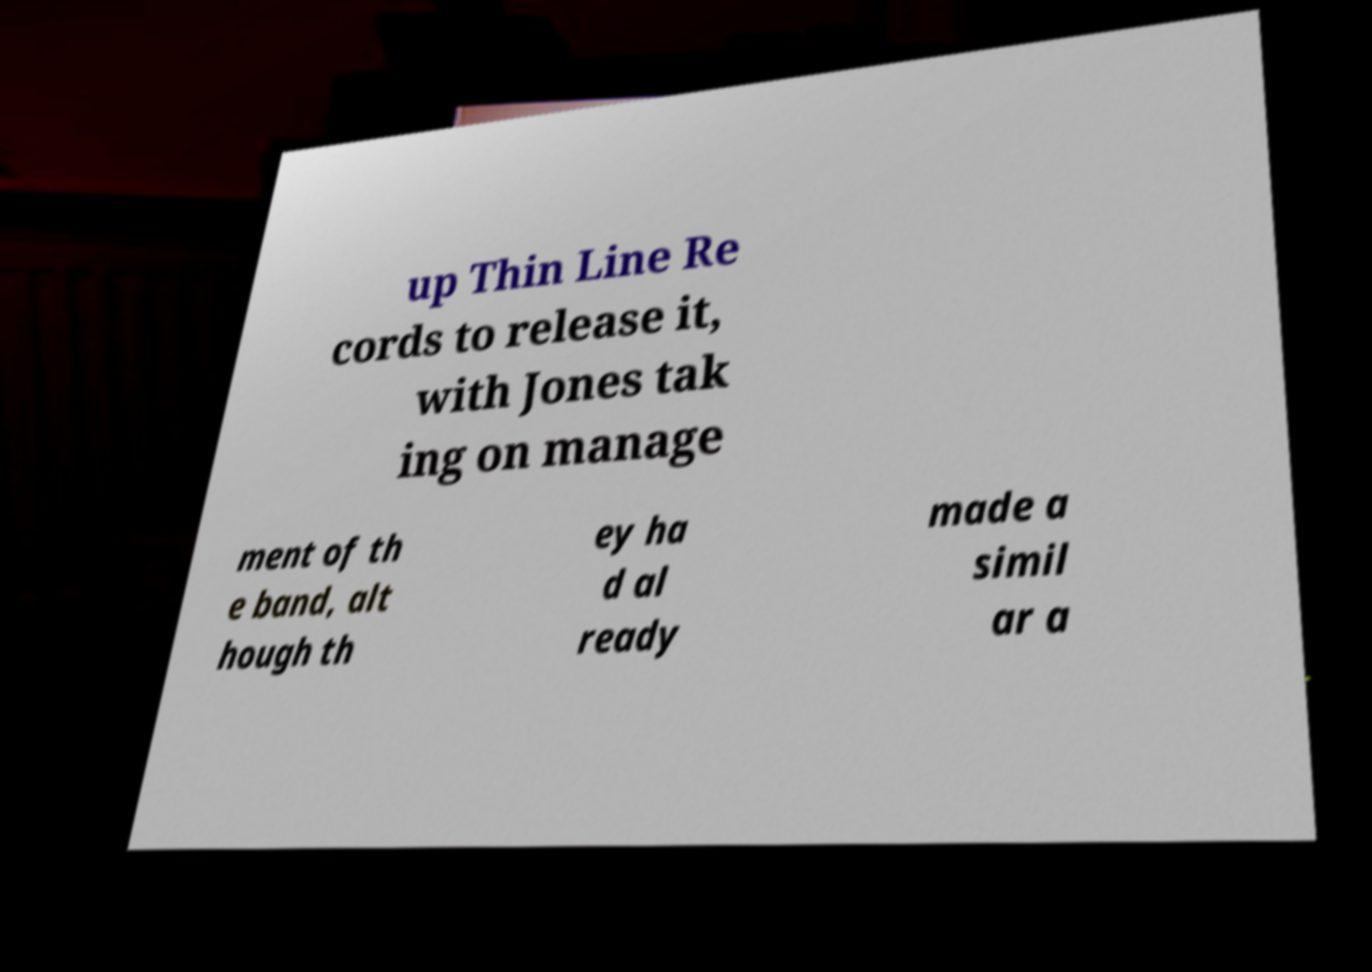Could you assist in decoding the text presented in this image and type it out clearly? up Thin Line Re cords to release it, with Jones tak ing on manage ment of th e band, alt hough th ey ha d al ready made a simil ar a 